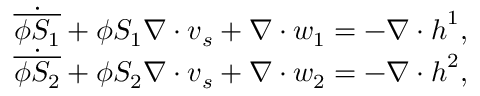<formula> <loc_0><loc_0><loc_500><loc_500>\begin{array} { r l } & { \dot { \overline { { \phi S _ { 1 } } } } + \phi S _ { 1 } \nabla \cdot v _ { s } + \nabla \cdot w _ { 1 } = - \nabla \cdot h ^ { 1 } , } \\ & { \dot { \overline { { \phi S _ { 2 } } } } + \phi S _ { 2 } \nabla \cdot v _ { s } + \nabla \cdot w _ { 2 } = - \nabla \cdot h ^ { 2 } , } \end{array}</formula> 